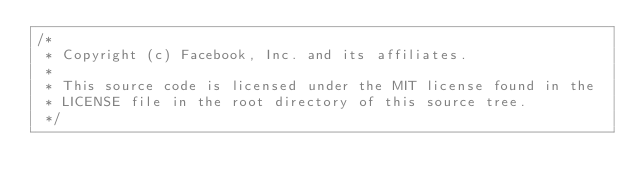<code> <loc_0><loc_0><loc_500><loc_500><_ObjectiveC_>/*
 * Copyright (c) Facebook, Inc. and its affiliates.
 *
 * This source code is licensed under the MIT license found in the
 * LICENSE file in the root directory of this source tree.
 */
</code> 